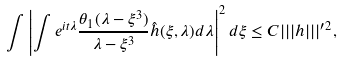Convert formula to latex. <formula><loc_0><loc_0><loc_500><loc_500>\int \left | \int e ^ { i t \lambda } \frac { \theta _ { 1 } ( \lambda - \xi ^ { 3 } ) } { \lambda - \xi ^ { 3 } } \hat { h } ( \xi , \lambda ) d \lambda \right | ^ { 2 } d \xi \leq C | | | h | | | ^ { \prime 2 } ,</formula> 